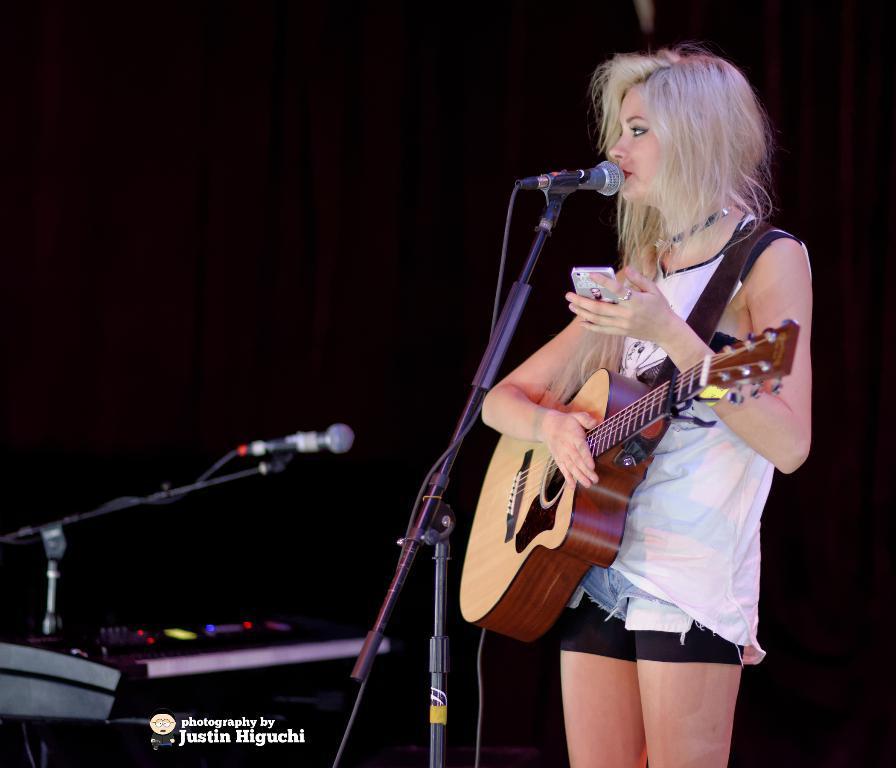Please provide a concise description of this image. In this image, There is a woman standing and carrying some music instrument and she is holding a mobile in her hand there is a microphone she is singing in microphone, In the left side there is a microphone in black color, In the background there is a black color wall. 